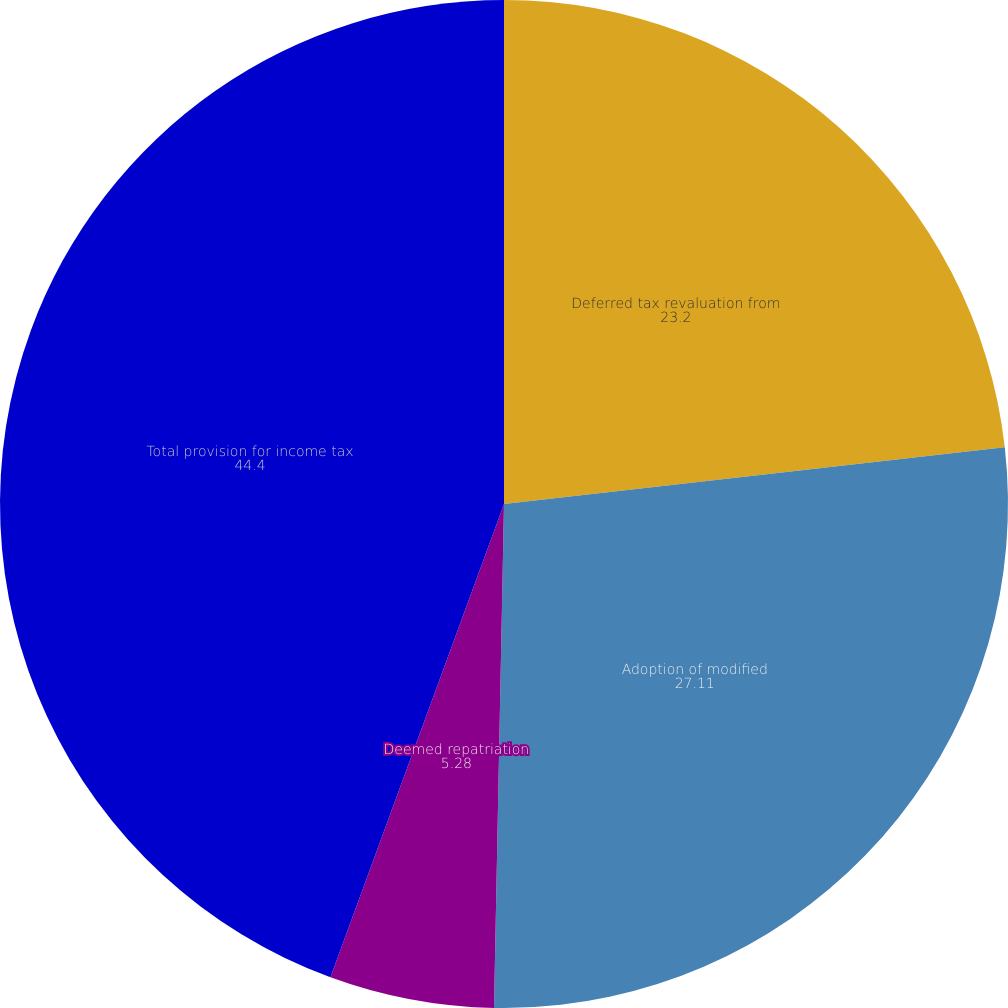<chart> <loc_0><loc_0><loc_500><loc_500><pie_chart><fcel>Deferred tax revaluation from<fcel>Adoption of modified<fcel>Deemed repatriation<fcel>Total provision for income tax<nl><fcel>23.2%<fcel>27.11%<fcel>5.28%<fcel>44.4%<nl></chart> 